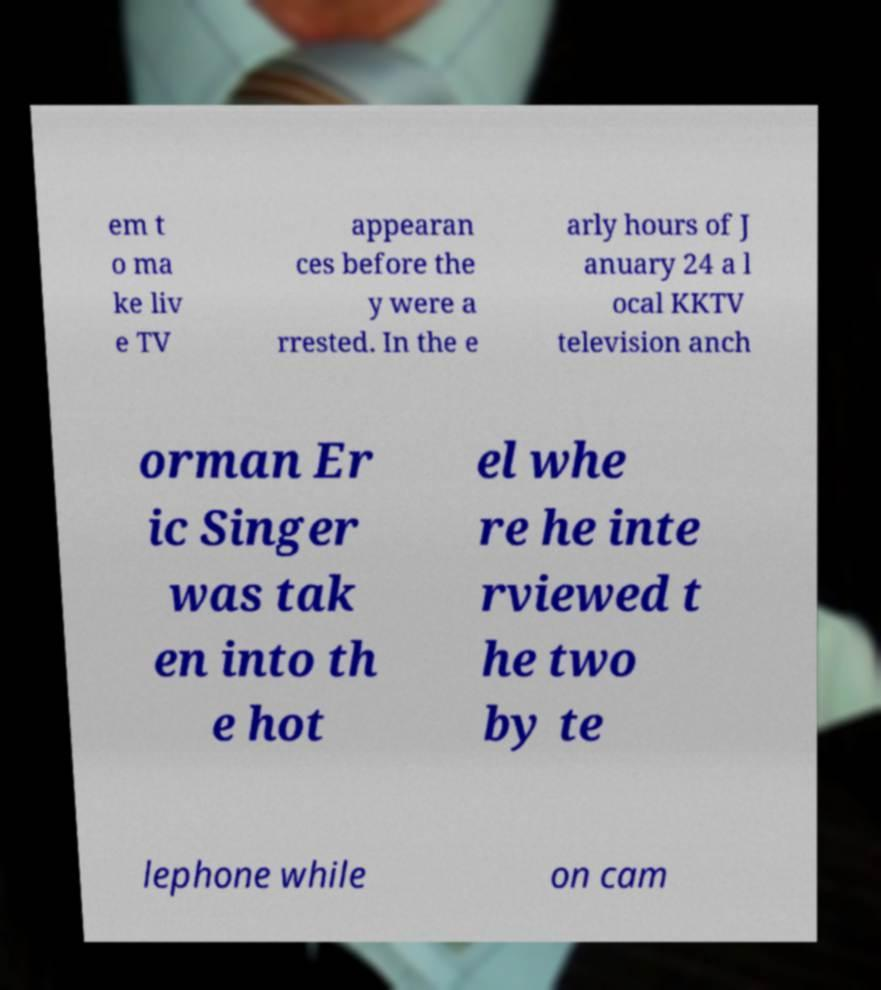There's text embedded in this image that I need extracted. Can you transcribe it verbatim? em t o ma ke liv e TV appearan ces before the y were a rrested. In the e arly hours of J anuary 24 a l ocal KKTV television anch orman Er ic Singer was tak en into th e hot el whe re he inte rviewed t he two by te lephone while on cam 